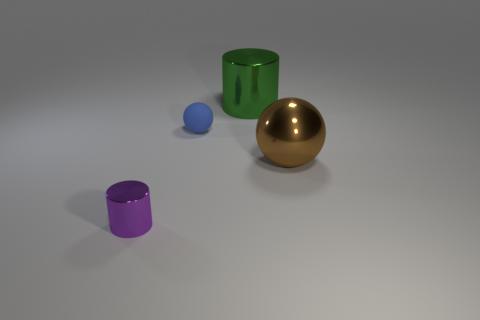Do the blue object and the cylinder in front of the brown shiny sphere have the same material?
Your response must be concise. No. Is there anything else that is the same shape as the purple shiny object?
Keep it short and to the point. Yes. Do the small blue thing and the large brown ball have the same material?
Ensure brevity in your answer.  No. There is a metal thing behind the tiny blue sphere; are there any balls to the right of it?
Provide a succinct answer. Yes. How many shiny cylinders are both in front of the big brown shiny sphere and right of the purple cylinder?
Offer a terse response. 0. What shape is the large thing behind the brown shiny thing?
Give a very brief answer. Cylinder. What number of purple metal things have the same size as the rubber ball?
Your answer should be compact. 1. Does the metallic thing that is on the left side of the big green object have the same color as the big metal cylinder?
Ensure brevity in your answer.  No. There is a object that is in front of the rubber sphere and behind the tiny purple cylinder; what material is it?
Your answer should be very brief. Metal. Is the number of tiny purple metallic balls greater than the number of blue spheres?
Provide a short and direct response. No. 